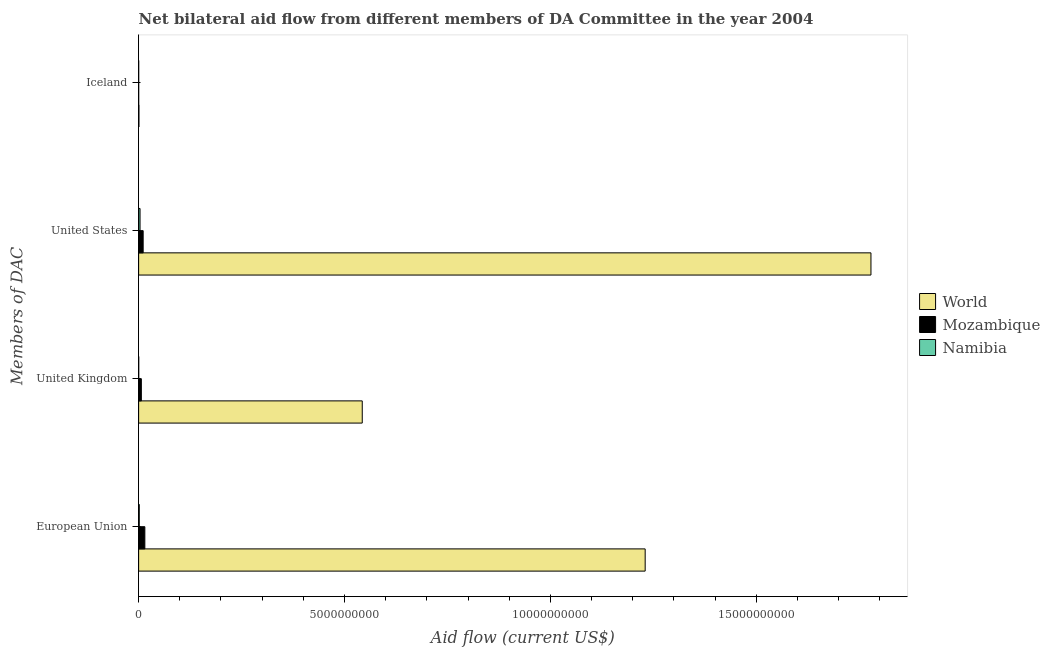How many groups of bars are there?
Your response must be concise. 4. How many bars are there on the 2nd tick from the top?
Provide a short and direct response. 3. How many bars are there on the 2nd tick from the bottom?
Your response must be concise. 3. What is the label of the 3rd group of bars from the top?
Your answer should be compact. United Kingdom. What is the amount of aid given by us in Namibia?
Make the answer very short. 3.43e+07. Across all countries, what is the maximum amount of aid given by iceland?
Provide a short and direct response. 7.60e+06. Across all countries, what is the minimum amount of aid given by iceland?
Your response must be concise. 1.24e+06. In which country was the amount of aid given by uk maximum?
Your answer should be compact. World. In which country was the amount of aid given by iceland minimum?
Your answer should be very brief. Mozambique. What is the total amount of aid given by uk in the graph?
Make the answer very short. 5.50e+09. What is the difference between the amount of aid given by eu in Mozambique and that in World?
Ensure brevity in your answer.  -1.22e+1. What is the difference between the amount of aid given by uk in Namibia and the amount of aid given by eu in Mozambique?
Offer a terse response. -1.48e+08. What is the average amount of aid given by uk per country?
Offer a very short reply. 1.83e+09. What is the difference between the amount of aid given by us and amount of aid given by uk in Mozambique?
Your answer should be very brief. 4.40e+07. What is the ratio of the amount of aid given by us in World to that in Namibia?
Give a very brief answer. 518.21. Is the difference between the amount of aid given by uk in Namibia and Mozambique greater than the difference between the amount of aid given by iceland in Namibia and Mozambique?
Offer a very short reply. No. What is the difference between the highest and the second highest amount of aid given by eu?
Offer a very short reply. 1.22e+1. What is the difference between the highest and the lowest amount of aid given by iceland?
Provide a succinct answer. 6.36e+06. Is the sum of the amount of aid given by iceland in Namibia and Mozambique greater than the maximum amount of aid given by eu across all countries?
Provide a short and direct response. No. Is it the case that in every country, the sum of the amount of aid given by iceland and amount of aid given by uk is greater than the sum of amount of aid given by us and amount of aid given by eu?
Your answer should be compact. Yes. What does the 2nd bar from the top in United Kingdom represents?
Give a very brief answer. Mozambique. What does the 2nd bar from the bottom in Iceland represents?
Offer a terse response. Mozambique. Does the graph contain any zero values?
Provide a short and direct response. No. What is the title of the graph?
Provide a short and direct response. Net bilateral aid flow from different members of DA Committee in the year 2004. Does "Sierra Leone" appear as one of the legend labels in the graph?
Provide a short and direct response. No. What is the label or title of the X-axis?
Provide a succinct answer. Aid flow (current US$). What is the label or title of the Y-axis?
Your answer should be compact. Members of DAC. What is the Aid flow (current US$) of World in European Union?
Keep it short and to the point. 1.23e+1. What is the Aid flow (current US$) of Mozambique in European Union?
Make the answer very short. 1.51e+08. What is the Aid flow (current US$) in Namibia in European Union?
Your answer should be compact. 1.54e+07. What is the Aid flow (current US$) in World in United Kingdom?
Your answer should be very brief. 5.43e+09. What is the Aid flow (current US$) of Mozambique in United Kingdom?
Keep it short and to the point. 6.59e+07. What is the Aid flow (current US$) in Namibia in United Kingdom?
Your answer should be compact. 2.73e+06. What is the Aid flow (current US$) of World in United States?
Keep it short and to the point. 1.78e+1. What is the Aid flow (current US$) of Mozambique in United States?
Give a very brief answer. 1.10e+08. What is the Aid flow (current US$) of Namibia in United States?
Offer a terse response. 3.43e+07. What is the Aid flow (current US$) of World in Iceland?
Your response must be concise. 7.60e+06. What is the Aid flow (current US$) in Mozambique in Iceland?
Your answer should be compact. 1.24e+06. What is the Aid flow (current US$) of Namibia in Iceland?
Offer a very short reply. 1.27e+06. Across all Members of DAC, what is the maximum Aid flow (current US$) in World?
Your answer should be very brief. 1.78e+1. Across all Members of DAC, what is the maximum Aid flow (current US$) in Mozambique?
Offer a very short reply. 1.51e+08. Across all Members of DAC, what is the maximum Aid flow (current US$) of Namibia?
Offer a terse response. 3.43e+07. Across all Members of DAC, what is the minimum Aid flow (current US$) in World?
Make the answer very short. 7.60e+06. Across all Members of DAC, what is the minimum Aid flow (current US$) of Mozambique?
Provide a succinct answer. 1.24e+06. Across all Members of DAC, what is the minimum Aid flow (current US$) in Namibia?
Your response must be concise. 1.27e+06. What is the total Aid flow (current US$) of World in the graph?
Offer a terse response. 3.55e+1. What is the total Aid flow (current US$) in Mozambique in the graph?
Make the answer very short. 3.28e+08. What is the total Aid flow (current US$) of Namibia in the graph?
Keep it short and to the point. 5.37e+07. What is the difference between the Aid flow (current US$) of World in European Union and that in United Kingdom?
Your answer should be very brief. 6.87e+09. What is the difference between the Aid flow (current US$) of Mozambique in European Union and that in United Kingdom?
Offer a terse response. 8.52e+07. What is the difference between the Aid flow (current US$) of Namibia in European Union and that in United Kingdom?
Give a very brief answer. 1.26e+07. What is the difference between the Aid flow (current US$) in World in European Union and that in United States?
Offer a terse response. -5.48e+09. What is the difference between the Aid flow (current US$) of Mozambique in European Union and that in United States?
Offer a very short reply. 4.11e+07. What is the difference between the Aid flow (current US$) of Namibia in European Union and that in United States?
Keep it short and to the point. -1.90e+07. What is the difference between the Aid flow (current US$) of World in European Union and that in Iceland?
Offer a very short reply. 1.23e+1. What is the difference between the Aid flow (current US$) in Mozambique in European Union and that in Iceland?
Offer a terse response. 1.50e+08. What is the difference between the Aid flow (current US$) of Namibia in European Union and that in Iceland?
Keep it short and to the point. 1.41e+07. What is the difference between the Aid flow (current US$) in World in United Kingdom and that in United States?
Offer a terse response. -1.24e+1. What is the difference between the Aid flow (current US$) of Mozambique in United Kingdom and that in United States?
Your answer should be compact. -4.40e+07. What is the difference between the Aid flow (current US$) of Namibia in United Kingdom and that in United States?
Provide a short and direct response. -3.16e+07. What is the difference between the Aid flow (current US$) of World in United Kingdom and that in Iceland?
Provide a short and direct response. 5.42e+09. What is the difference between the Aid flow (current US$) of Mozambique in United Kingdom and that in Iceland?
Your response must be concise. 6.47e+07. What is the difference between the Aid flow (current US$) in Namibia in United Kingdom and that in Iceland?
Your answer should be very brief. 1.46e+06. What is the difference between the Aid flow (current US$) in World in United States and that in Iceland?
Ensure brevity in your answer.  1.78e+1. What is the difference between the Aid flow (current US$) of Mozambique in United States and that in Iceland?
Make the answer very short. 1.09e+08. What is the difference between the Aid flow (current US$) in Namibia in United States and that in Iceland?
Provide a short and direct response. 3.30e+07. What is the difference between the Aid flow (current US$) in World in European Union and the Aid flow (current US$) in Mozambique in United Kingdom?
Offer a very short reply. 1.22e+1. What is the difference between the Aid flow (current US$) of World in European Union and the Aid flow (current US$) of Namibia in United Kingdom?
Offer a very short reply. 1.23e+1. What is the difference between the Aid flow (current US$) in Mozambique in European Union and the Aid flow (current US$) in Namibia in United Kingdom?
Provide a short and direct response. 1.48e+08. What is the difference between the Aid flow (current US$) in World in European Union and the Aid flow (current US$) in Mozambique in United States?
Your response must be concise. 1.22e+1. What is the difference between the Aid flow (current US$) of World in European Union and the Aid flow (current US$) of Namibia in United States?
Provide a short and direct response. 1.23e+1. What is the difference between the Aid flow (current US$) of Mozambique in European Union and the Aid flow (current US$) of Namibia in United States?
Offer a terse response. 1.17e+08. What is the difference between the Aid flow (current US$) of World in European Union and the Aid flow (current US$) of Mozambique in Iceland?
Give a very brief answer. 1.23e+1. What is the difference between the Aid flow (current US$) of World in European Union and the Aid flow (current US$) of Namibia in Iceland?
Ensure brevity in your answer.  1.23e+1. What is the difference between the Aid flow (current US$) in Mozambique in European Union and the Aid flow (current US$) in Namibia in Iceland?
Provide a short and direct response. 1.50e+08. What is the difference between the Aid flow (current US$) in World in United Kingdom and the Aid flow (current US$) in Mozambique in United States?
Your answer should be very brief. 5.32e+09. What is the difference between the Aid flow (current US$) of World in United Kingdom and the Aid flow (current US$) of Namibia in United States?
Keep it short and to the point. 5.40e+09. What is the difference between the Aid flow (current US$) of Mozambique in United Kingdom and the Aid flow (current US$) of Namibia in United States?
Offer a terse response. 3.16e+07. What is the difference between the Aid flow (current US$) of World in United Kingdom and the Aid flow (current US$) of Mozambique in Iceland?
Offer a very short reply. 5.43e+09. What is the difference between the Aid flow (current US$) of World in United Kingdom and the Aid flow (current US$) of Namibia in Iceland?
Give a very brief answer. 5.43e+09. What is the difference between the Aid flow (current US$) in Mozambique in United Kingdom and the Aid flow (current US$) in Namibia in Iceland?
Your answer should be compact. 6.46e+07. What is the difference between the Aid flow (current US$) in World in United States and the Aid flow (current US$) in Mozambique in Iceland?
Your answer should be very brief. 1.78e+1. What is the difference between the Aid flow (current US$) of World in United States and the Aid flow (current US$) of Namibia in Iceland?
Give a very brief answer. 1.78e+1. What is the difference between the Aid flow (current US$) in Mozambique in United States and the Aid flow (current US$) in Namibia in Iceland?
Your answer should be compact. 1.09e+08. What is the average Aid flow (current US$) of World per Members of DAC?
Make the answer very short. 8.88e+09. What is the average Aid flow (current US$) of Mozambique per Members of DAC?
Offer a terse response. 8.21e+07. What is the average Aid flow (current US$) of Namibia per Members of DAC?
Provide a short and direct response. 1.34e+07. What is the difference between the Aid flow (current US$) of World and Aid flow (current US$) of Mozambique in European Union?
Your answer should be very brief. 1.22e+1. What is the difference between the Aid flow (current US$) in World and Aid flow (current US$) in Namibia in European Union?
Your response must be concise. 1.23e+1. What is the difference between the Aid flow (current US$) in Mozambique and Aid flow (current US$) in Namibia in European Union?
Give a very brief answer. 1.36e+08. What is the difference between the Aid flow (current US$) in World and Aid flow (current US$) in Mozambique in United Kingdom?
Keep it short and to the point. 5.36e+09. What is the difference between the Aid flow (current US$) in World and Aid flow (current US$) in Namibia in United Kingdom?
Offer a very short reply. 5.43e+09. What is the difference between the Aid flow (current US$) in Mozambique and Aid flow (current US$) in Namibia in United Kingdom?
Make the answer very short. 6.32e+07. What is the difference between the Aid flow (current US$) in World and Aid flow (current US$) in Mozambique in United States?
Offer a terse response. 1.77e+1. What is the difference between the Aid flow (current US$) in World and Aid flow (current US$) in Namibia in United States?
Offer a very short reply. 1.78e+1. What is the difference between the Aid flow (current US$) of Mozambique and Aid flow (current US$) of Namibia in United States?
Your response must be concise. 7.56e+07. What is the difference between the Aid flow (current US$) of World and Aid flow (current US$) of Mozambique in Iceland?
Keep it short and to the point. 6.36e+06. What is the difference between the Aid flow (current US$) of World and Aid flow (current US$) of Namibia in Iceland?
Your answer should be very brief. 6.33e+06. What is the ratio of the Aid flow (current US$) of World in European Union to that in United Kingdom?
Your answer should be compact. 2.27. What is the ratio of the Aid flow (current US$) in Mozambique in European Union to that in United Kingdom?
Provide a succinct answer. 2.29. What is the ratio of the Aid flow (current US$) in Namibia in European Union to that in United Kingdom?
Provide a succinct answer. 5.63. What is the ratio of the Aid flow (current US$) of World in European Union to that in United States?
Give a very brief answer. 0.69. What is the ratio of the Aid flow (current US$) of Mozambique in European Union to that in United States?
Offer a very short reply. 1.37. What is the ratio of the Aid flow (current US$) of Namibia in European Union to that in United States?
Your answer should be very brief. 0.45. What is the ratio of the Aid flow (current US$) of World in European Union to that in Iceland?
Your answer should be compact. 1618.65. What is the ratio of the Aid flow (current US$) in Mozambique in European Union to that in Iceland?
Ensure brevity in your answer.  121.85. What is the ratio of the Aid flow (current US$) in Namibia in European Union to that in Iceland?
Provide a succinct answer. 12.09. What is the ratio of the Aid flow (current US$) in World in United Kingdom to that in United States?
Offer a terse response. 0.31. What is the ratio of the Aid flow (current US$) of Mozambique in United Kingdom to that in United States?
Make the answer very short. 0.6. What is the ratio of the Aid flow (current US$) in Namibia in United Kingdom to that in United States?
Your answer should be very brief. 0.08. What is the ratio of the Aid flow (current US$) in World in United Kingdom to that in Iceland?
Offer a terse response. 714.59. What is the ratio of the Aid flow (current US$) of Mozambique in United Kingdom to that in Iceland?
Keep it short and to the point. 53.16. What is the ratio of the Aid flow (current US$) of Namibia in United Kingdom to that in Iceland?
Offer a terse response. 2.15. What is the ratio of the Aid flow (current US$) in World in United States to that in Iceland?
Your response must be concise. 2340.13. What is the ratio of the Aid flow (current US$) in Mozambique in United States to that in Iceland?
Give a very brief answer. 88.68. What is the ratio of the Aid flow (current US$) in Namibia in United States to that in Iceland?
Give a very brief answer. 27.02. What is the difference between the highest and the second highest Aid flow (current US$) of World?
Your answer should be very brief. 5.48e+09. What is the difference between the highest and the second highest Aid flow (current US$) in Mozambique?
Your response must be concise. 4.11e+07. What is the difference between the highest and the second highest Aid flow (current US$) of Namibia?
Your answer should be very brief. 1.90e+07. What is the difference between the highest and the lowest Aid flow (current US$) of World?
Offer a very short reply. 1.78e+1. What is the difference between the highest and the lowest Aid flow (current US$) in Mozambique?
Ensure brevity in your answer.  1.50e+08. What is the difference between the highest and the lowest Aid flow (current US$) in Namibia?
Keep it short and to the point. 3.30e+07. 